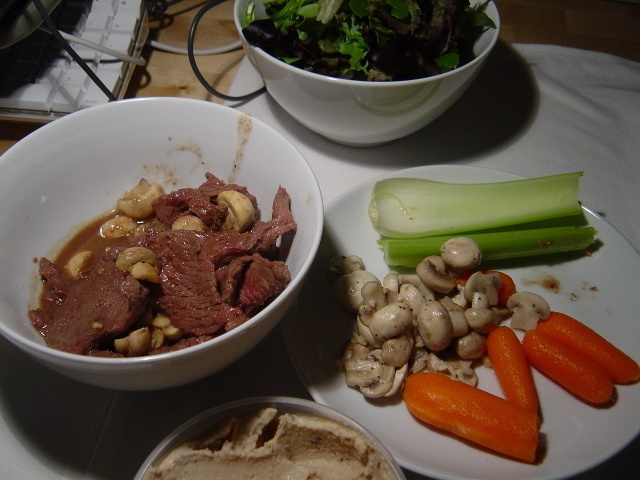Describe the objects in this image and their specific colors. I can see bowl in black, darkgray, and maroon tones, bowl in black, gray, darkgreen, and darkgray tones, bowl in black, gray, and maroon tones, keyboard in black, darkgray, and gray tones, and carrot in black, maroon, brown, and gray tones in this image. 